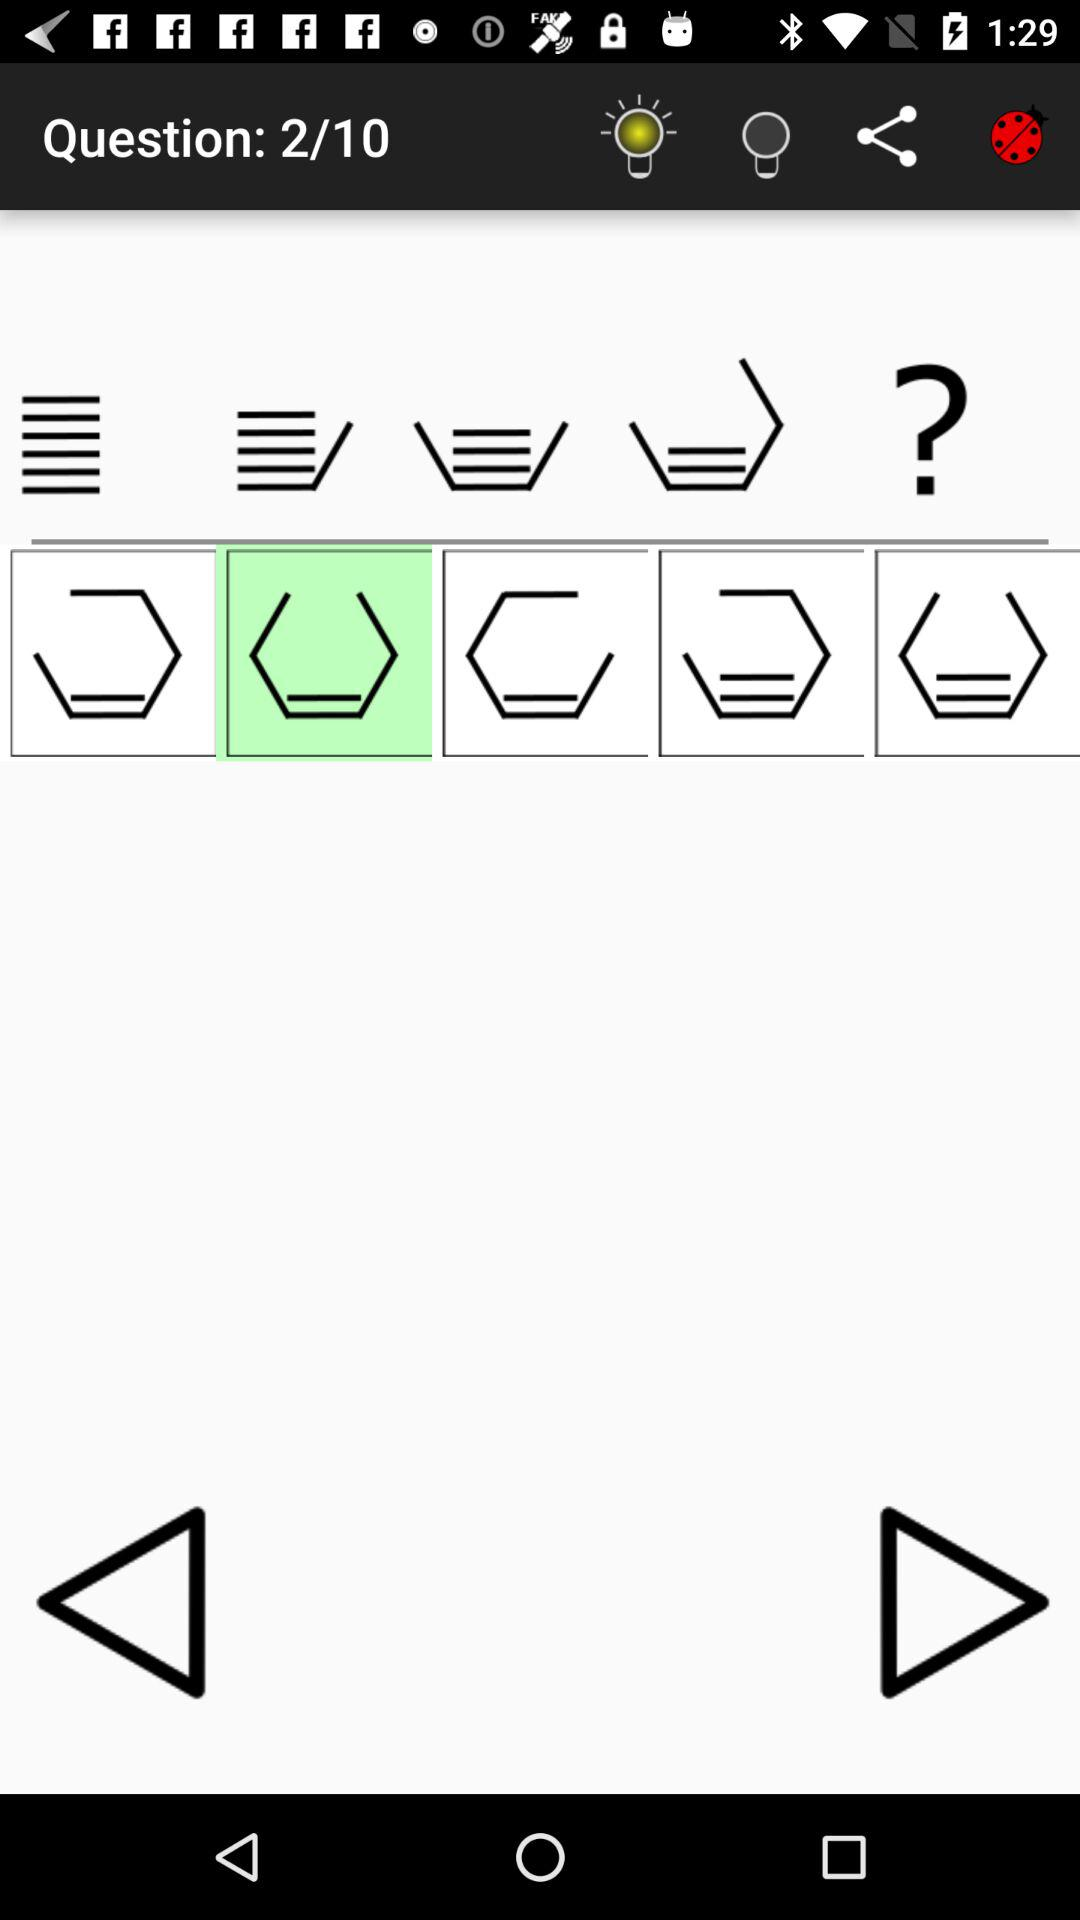How many questions in total are there? There are 10 questions. 